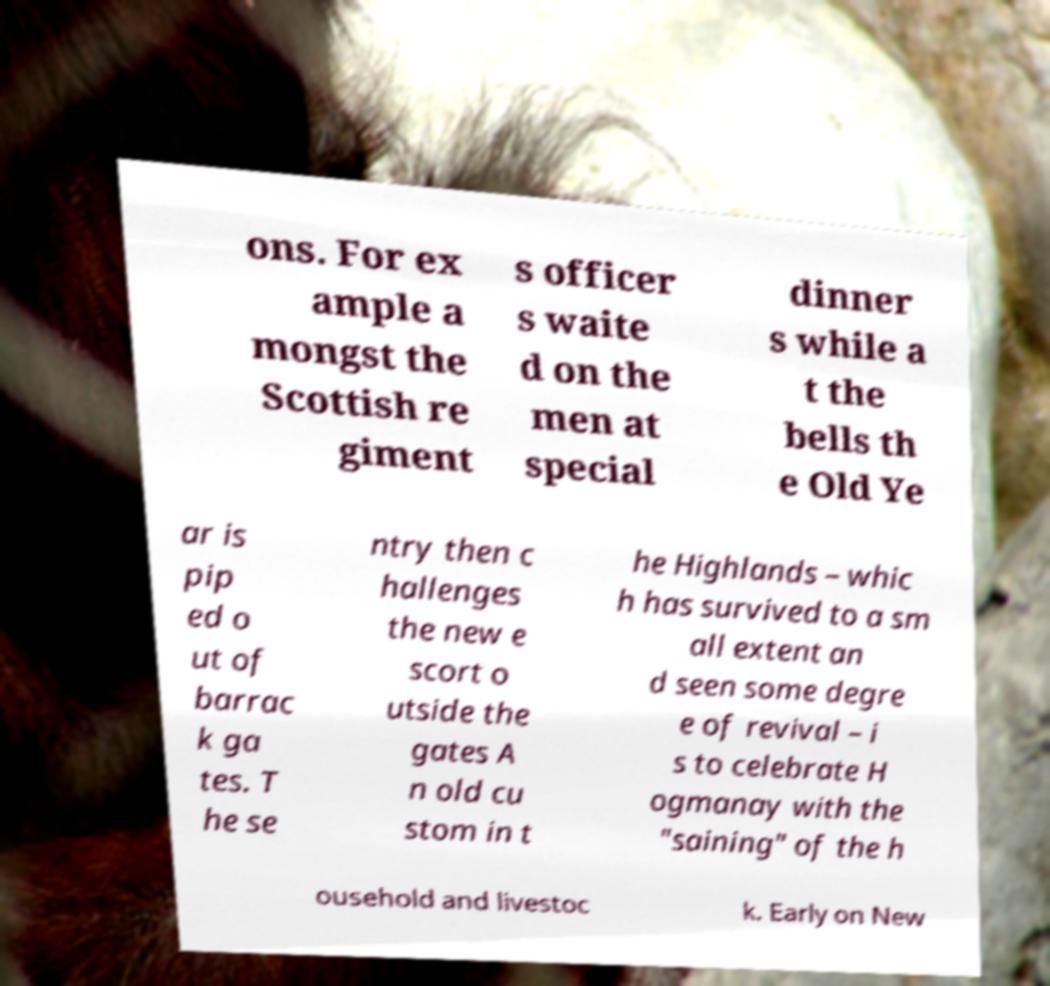Can you accurately transcribe the text from the provided image for me? ons. For ex ample a mongst the Scottish re giment s officer s waite d on the men at special dinner s while a t the bells th e Old Ye ar is pip ed o ut of barrac k ga tes. T he se ntry then c hallenges the new e scort o utside the gates A n old cu stom in t he Highlands – whic h has survived to a sm all extent an d seen some degre e of revival – i s to celebrate H ogmanay with the "saining" of the h ousehold and livestoc k. Early on New 